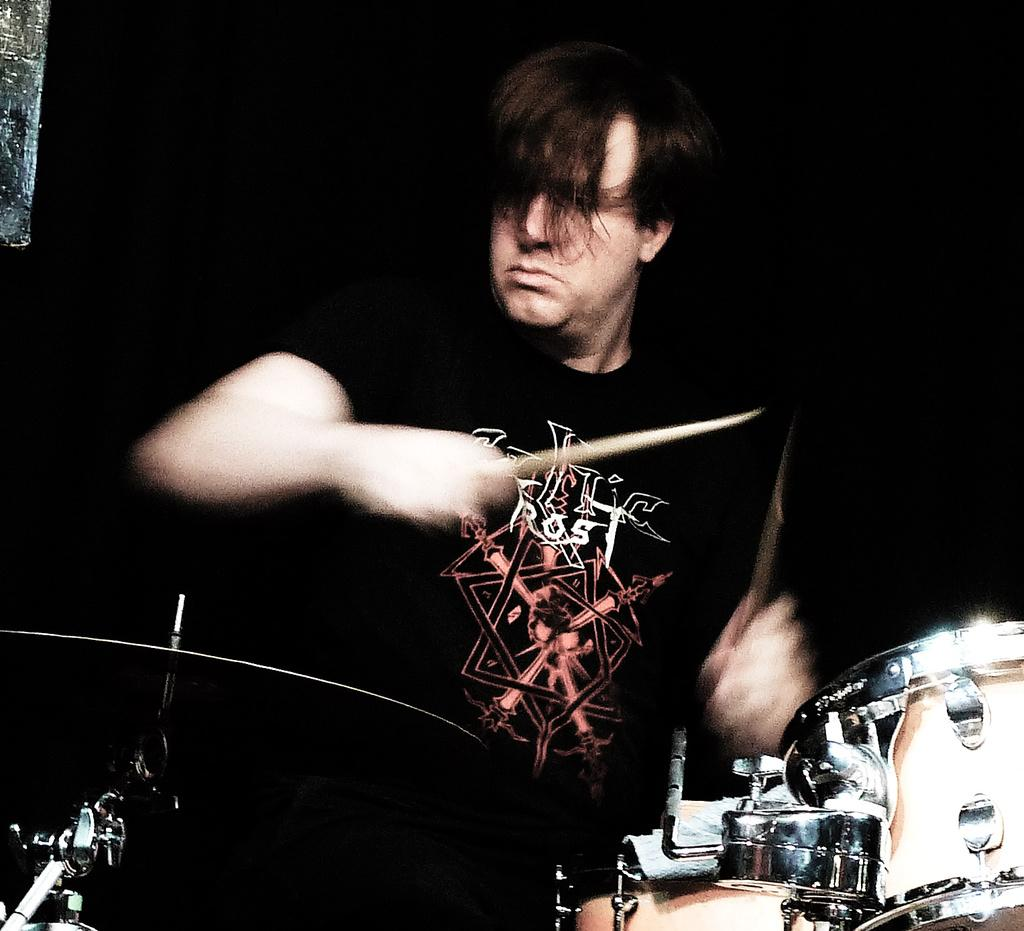What is the main subject of the image? There is a person in the image. What is the person holding in the image? The person is holding sticks. What else can be seen in the image besides the person? There are musical instruments and other objects in the image. Can you describe the background of the image? The background of the image is dark. What type of reward is the servant holding in the image? There is no servant or reward present in the image. What does the person hope to achieve by playing the musical instruments in the image? The image does not provide information about the person's hopes or intentions, so we cannot determine what they hope to achieve by playing the musical instruments. 